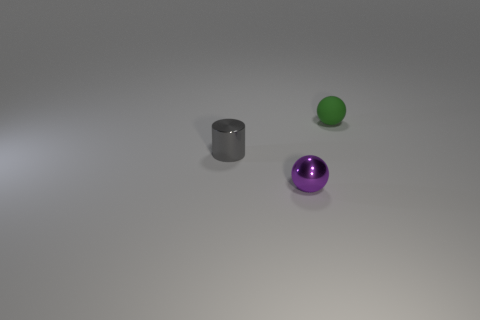What shape is the metallic thing in front of the tiny gray thing?
Your response must be concise. Sphere. There is a sphere on the left side of the matte object; is there a small gray metallic thing in front of it?
Your response must be concise. No. Are there any cyan things that have the same size as the green sphere?
Your answer should be compact. No. Does the small thing that is to the left of the purple metallic thing have the same color as the matte ball?
Ensure brevity in your answer.  No. How big is the green thing?
Provide a succinct answer. Small. How big is the ball that is on the right side of the ball in front of the tiny green matte sphere?
Ensure brevity in your answer.  Small. How many small brown metallic objects are there?
Keep it short and to the point. 0. How many small purple spheres are the same material as the green object?
Provide a short and direct response. 0. There is another object that is the same shape as the tiny rubber object; what is its size?
Offer a very short reply. Small. What material is the tiny green ball?
Give a very brief answer. Rubber. 